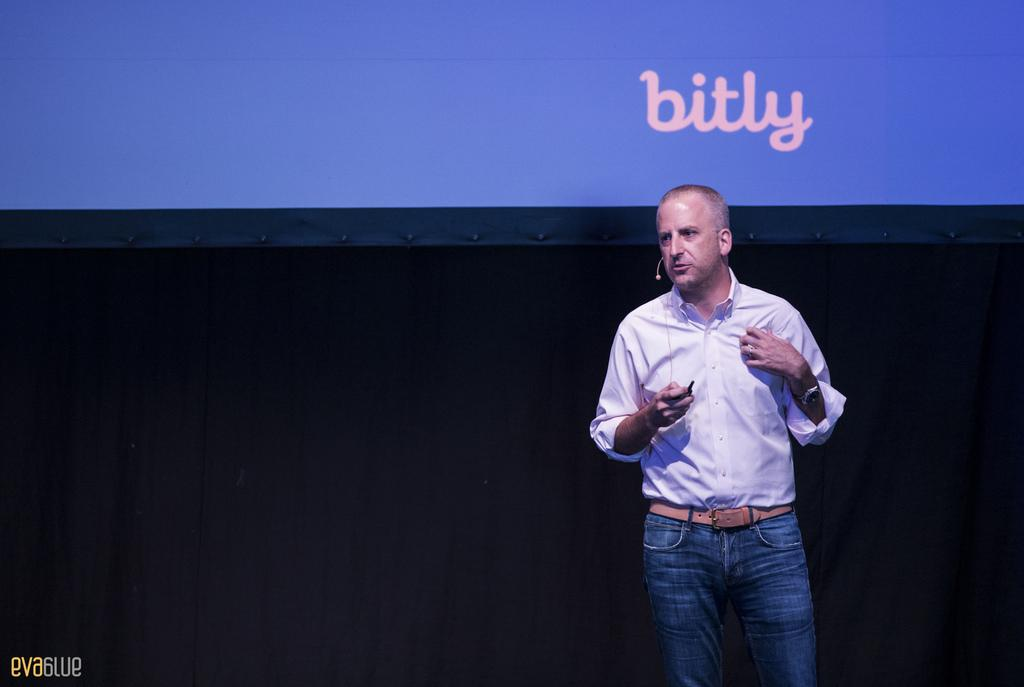What is the main subject of the image? There is a man standing in the image. Where is the man standing? The man is standing on the floor. What can be seen in the background of the image? There is a projector screen and a curtain in the background of the image. What type of pig can be seen sitting on the edge of the curtain in the image? There is no pig present in the image, and the curtain does not have an edge. 